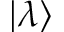<formula> <loc_0><loc_0><loc_500><loc_500>| \lambda \rangle</formula> 